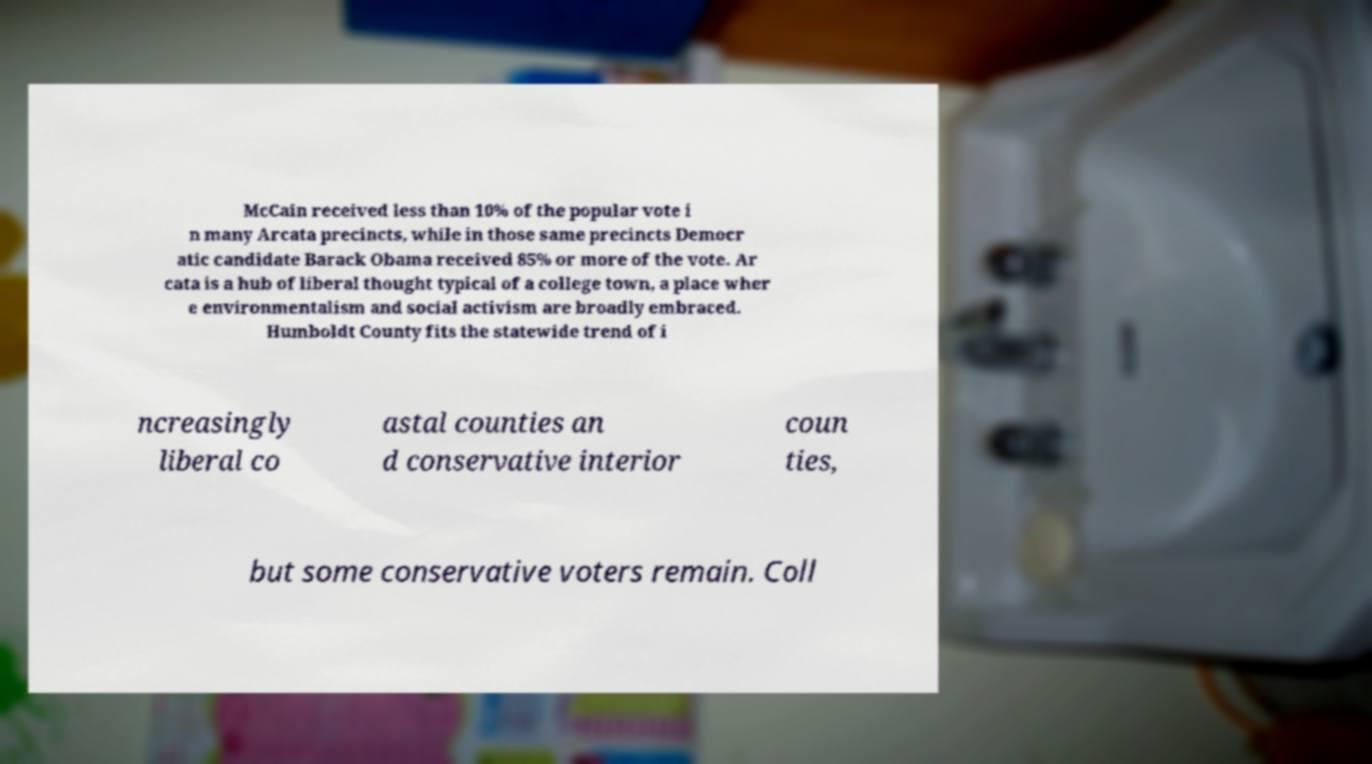There's text embedded in this image that I need extracted. Can you transcribe it verbatim? McCain received less than 10% of the popular vote i n many Arcata precincts, while in those same precincts Democr atic candidate Barack Obama received 85% or more of the vote. Ar cata is a hub of liberal thought typical of a college town, a place wher e environmentalism and social activism are broadly embraced. Humboldt County fits the statewide trend of i ncreasingly liberal co astal counties an d conservative interior coun ties, but some conservative voters remain. Coll 